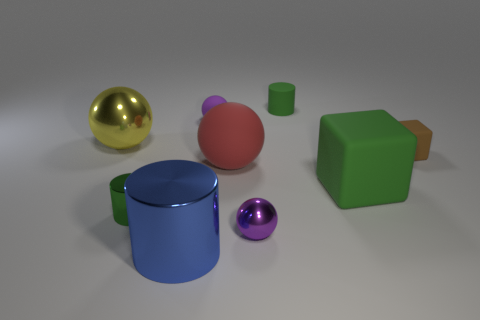Subtract 1 cylinders. How many cylinders are left? 2 Subtract all shiny cylinders. How many cylinders are left? 1 Subtract all brown spheres. Subtract all green cylinders. How many spheres are left? 4 Add 1 big metal balls. How many objects exist? 10 Subtract all spheres. How many objects are left? 5 Subtract all large cubes. Subtract all large matte spheres. How many objects are left? 7 Add 1 red things. How many red things are left? 2 Add 5 big red balls. How many big red balls exist? 6 Subtract 0 yellow blocks. How many objects are left? 9 